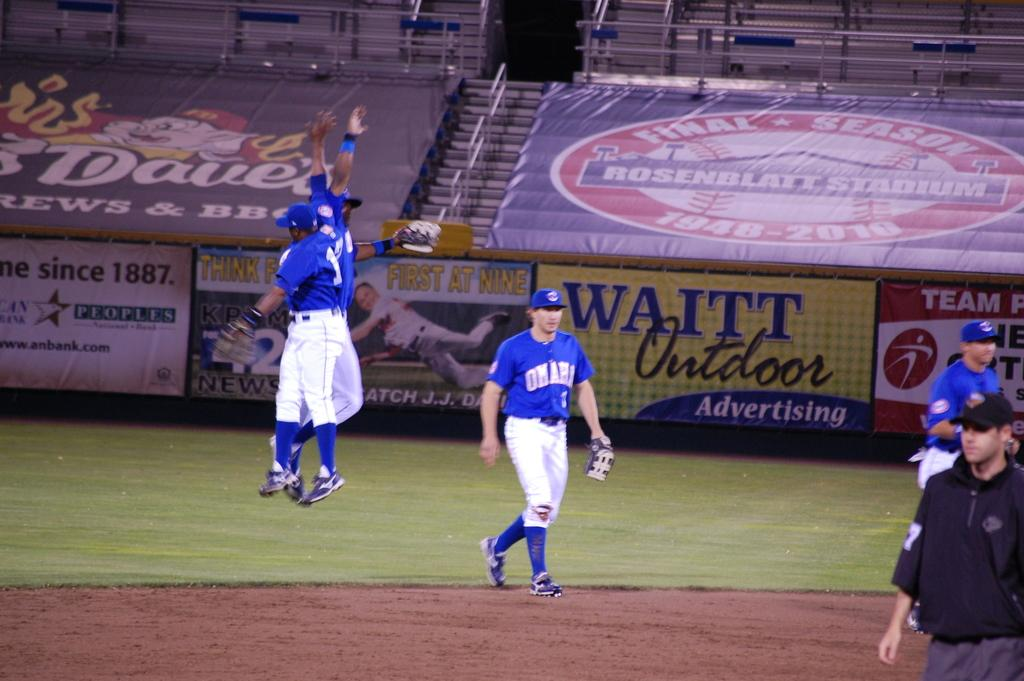<image>
Relay a brief, clear account of the picture shown. Baseball game with Waitt Outdoor Adverstising on the fence. 